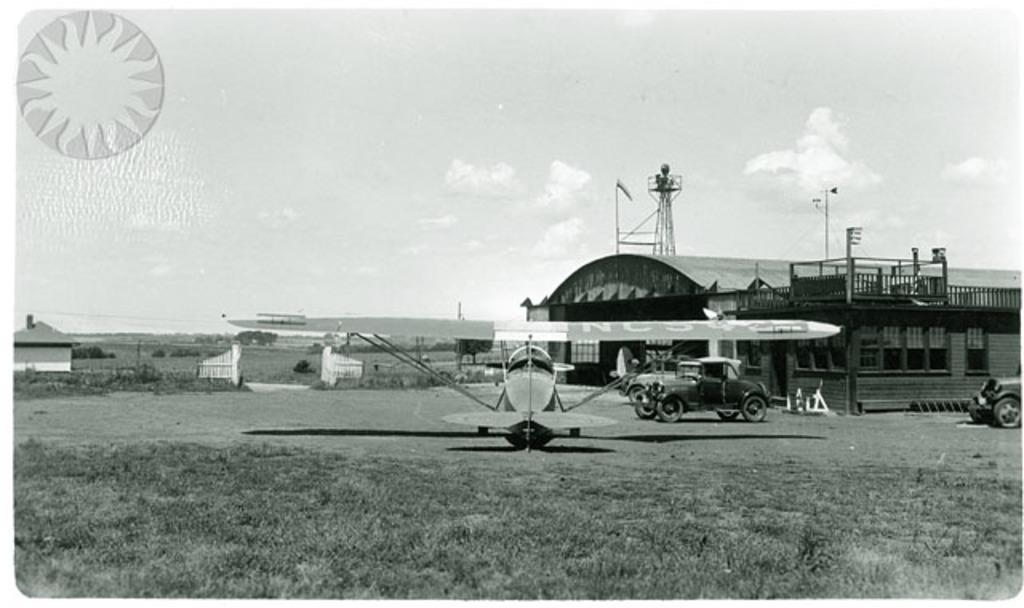Describe this image in one or two sentences. This picture is clicked outside. In the center there is an aircraft and we can see the vehicles and we can see the grass and a house. In the background we can see the sky, plants, metal rods and some other objects. In the top left corner we can see the logo on the image. 